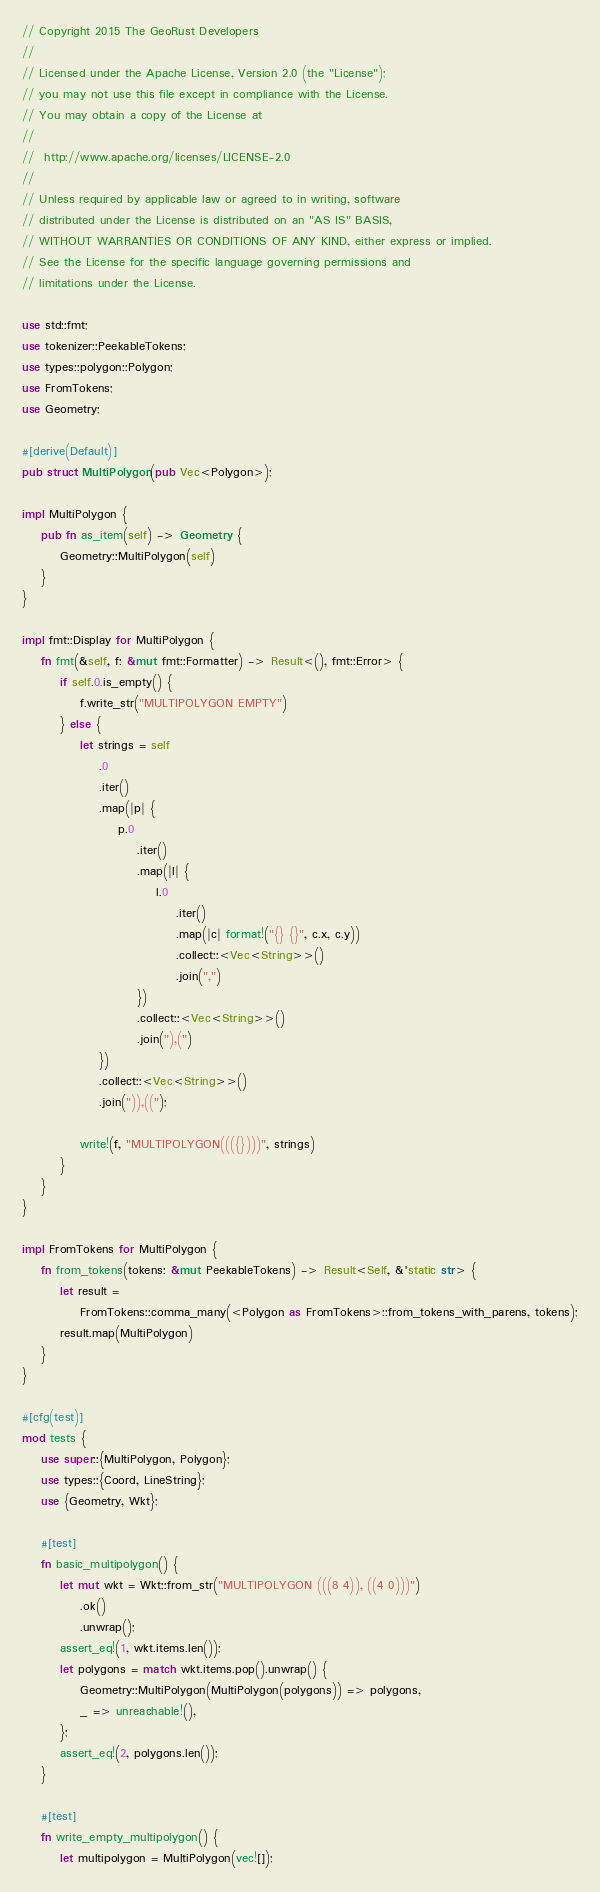Convert code to text. <code><loc_0><loc_0><loc_500><loc_500><_Rust_>// Copyright 2015 The GeoRust Developers
//
// Licensed under the Apache License, Version 2.0 (the "License");
// you may not use this file except in compliance with the License.
// You may obtain a copy of the License at
//
//	http://www.apache.org/licenses/LICENSE-2.0
//
// Unless required by applicable law or agreed to in writing, software
// distributed under the License is distributed on an "AS IS" BASIS,
// WITHOUT WARRANTIES OR CONDITIONS OF ANY KIND, either express or implied.
// See the License for the specific language governing permissions and
// limitations under the License.

use std::fmt;
use tokenizer::PeekableTokens;
use types::polygon::Polygon;
use FromTokens;
use Geometry;

#[derive(Default)]
pub struct MultiPolygon(pub Vec<Polygon>);

impl MultiPolygon {
    pub fn as_item(self) -> Geometry {
        Geometry::MultiPolygon(self)
    }
}

impl fmt::Display for MultiPolygon {
    fn fmt(&self, f: &mut fmt::Formatter) -> Result<(), fmt::Error> {
        if self.0.is_empty() {
            f.write_str("MULTIPOLYGON EMPTY")
        } else {
            let strings = self
                .0
                .iter()
                .map(|p| {
                    p.0
                        .iter()
                        .map(|l| {
                            l.0
                                .iter()
                                .map(|c| format!("{} {}", c.x, c.y))
                                .collect::<Vec<String>>()
                                .join(",")
                        })
                        .collect::<Vec<String>>()
                        .join("),(")
                })
                .collect::<Vec<String>>()
                .join(")),((");

            write!(f, "MULTIPOLYGON((({})))", strings)
        }
    }
}

impl FromTokens for MultiPolygon {
    fn from_tokens(tokens: &mut PeekableTokens) -> Result<Self, &'static str> {
        let result =
            FromTokens::comma_many(<Polygon as FromTokens>::from_tokens_with_parens, tokens);
        result.map(MultiPolygon)
    }
}

#[cfg(test)]
mod tests {
    use super::{MultiPolygon, Polygon};
    use types::{Coord, LineString};
    use {Geometry, Wkt};

    #[test]
    fn basic_multipolygon() {
        let mut wkt = Wkt::from_str("MULTIPOLYGON (((8 4)), ((4 0)))")
            .ok()
            .unwrap();
        assert_eq!(1, wkt.items.len());
        let polygons = match wkt.items.pop().unwrap() {
            Geometry::MultiPolygon(MultiPolygon(polygons)) => polygons,
            _ => unreachable!(),
        };
        assert_eq!(2, polygons.len());
    }

    #[test]
    fn write_empty_multipolygon() {
        let multipolygon = MultiPolygon(vec![]);
</code> 